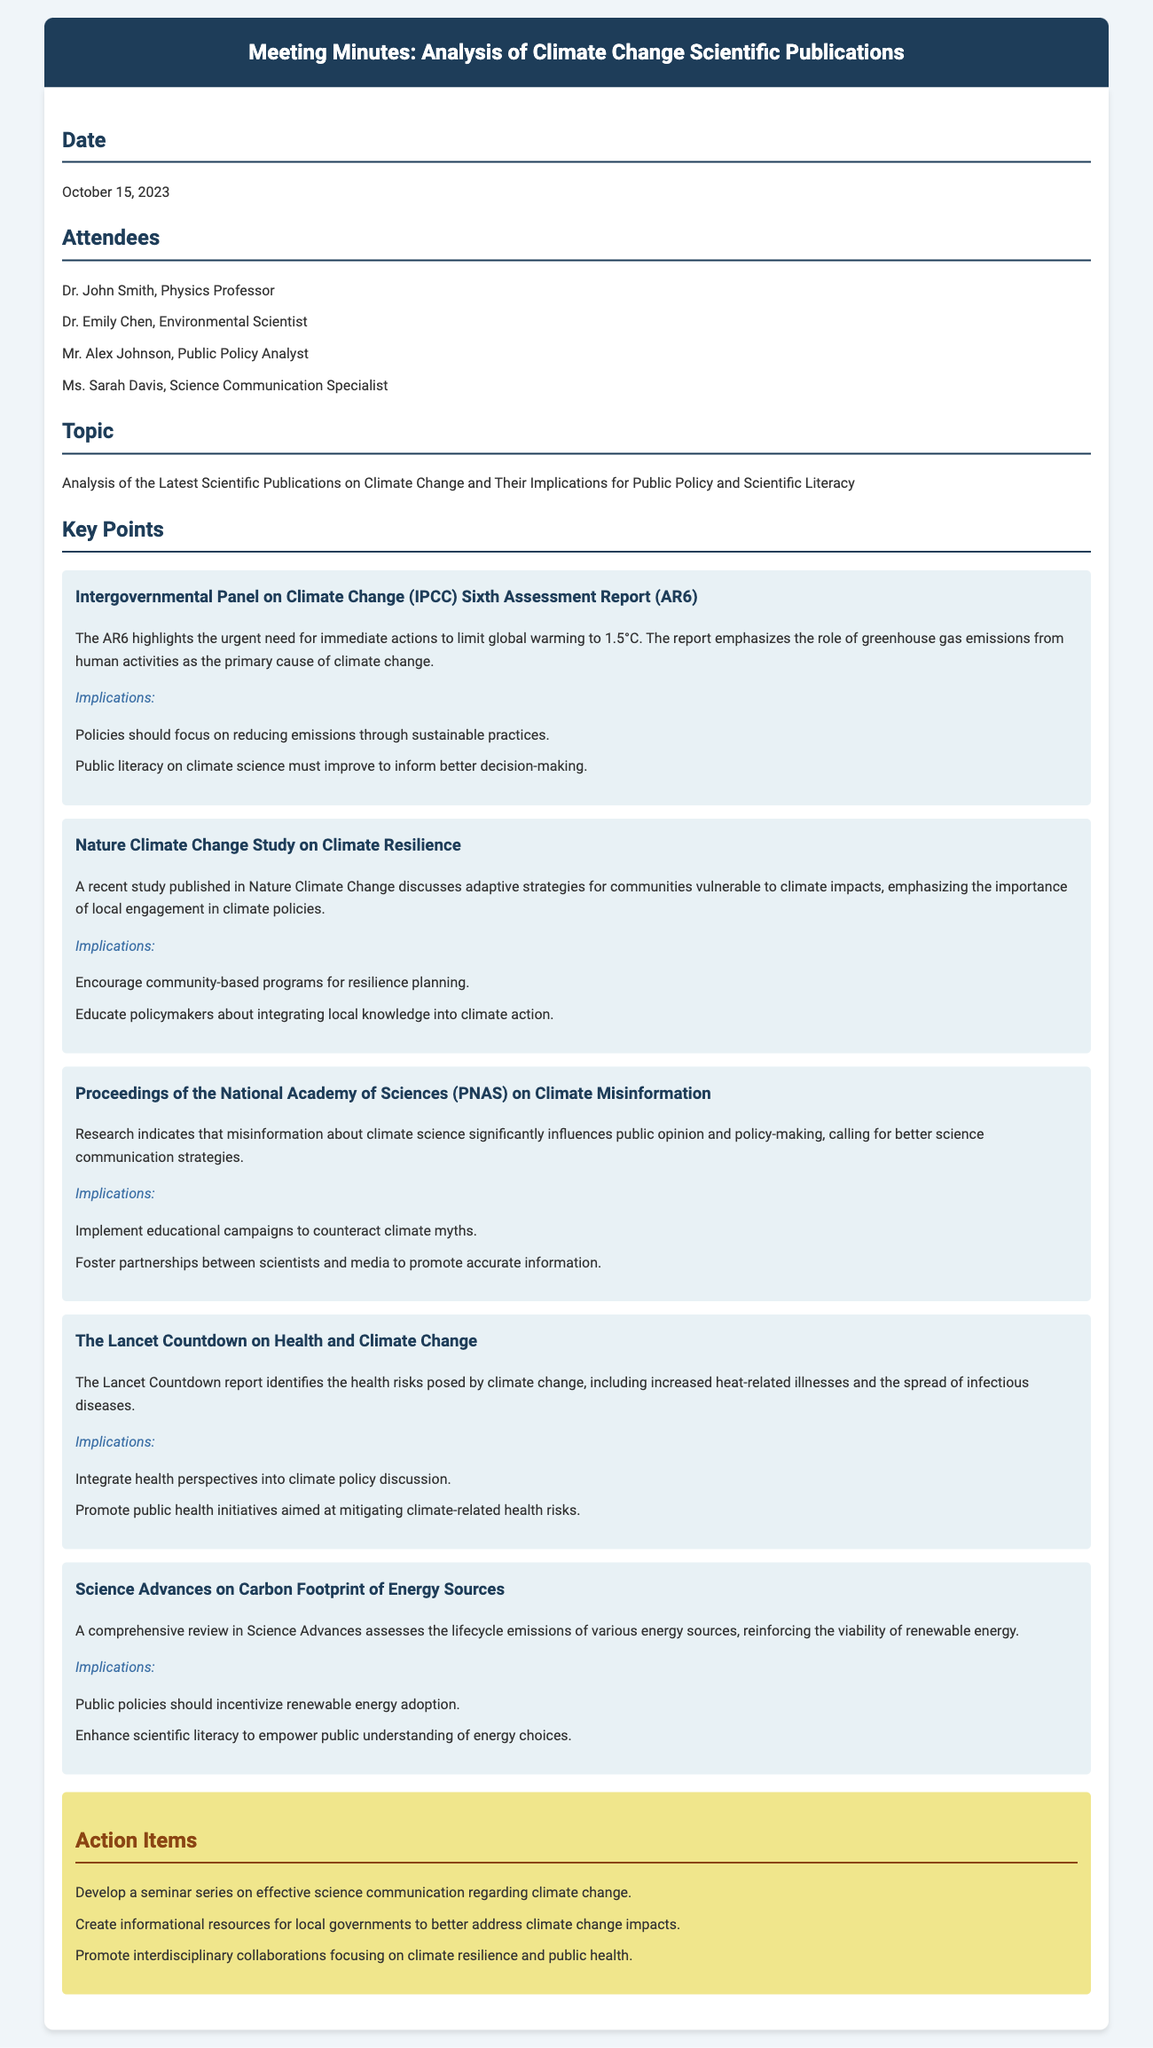what is the date of the meeting? The date of the meeting is explicitly mentioned in the document under the "Date" section.
Answer: October 15, 2023 who is the public policy analyst in attendance? The attendees list includes names and roles, allowing for identification of the public policy analyst.
Answer: Mr. Alex Johnson what study emphasizes local engagement in climate policies? The document references a specific study highlighting the importance of local engagement in its implications section.
Answer: Nature Climate Change Study how many action items are listed in the minutes? The action items section contains a list of specific tasks discussed in the meeting, which can be counted.
Answer: Three what major report calls for limiting global warming to 1.5°C? The key points section highlights a significant report that discusses limiting global warming, leading to identification of the specific report.
Answer: IPCC Sixth Assessment Report which report identifies health risks posed by climate change? The document lists several studies, one specifically addressing health risks associated with climate change issues.
Answer: The Lancet Countdown what is one implication from the Science Advances review? The implications section for each key point provides actionable insights derived from the research presented.
Answer: Public policies should incentivize renewable energy adoption 